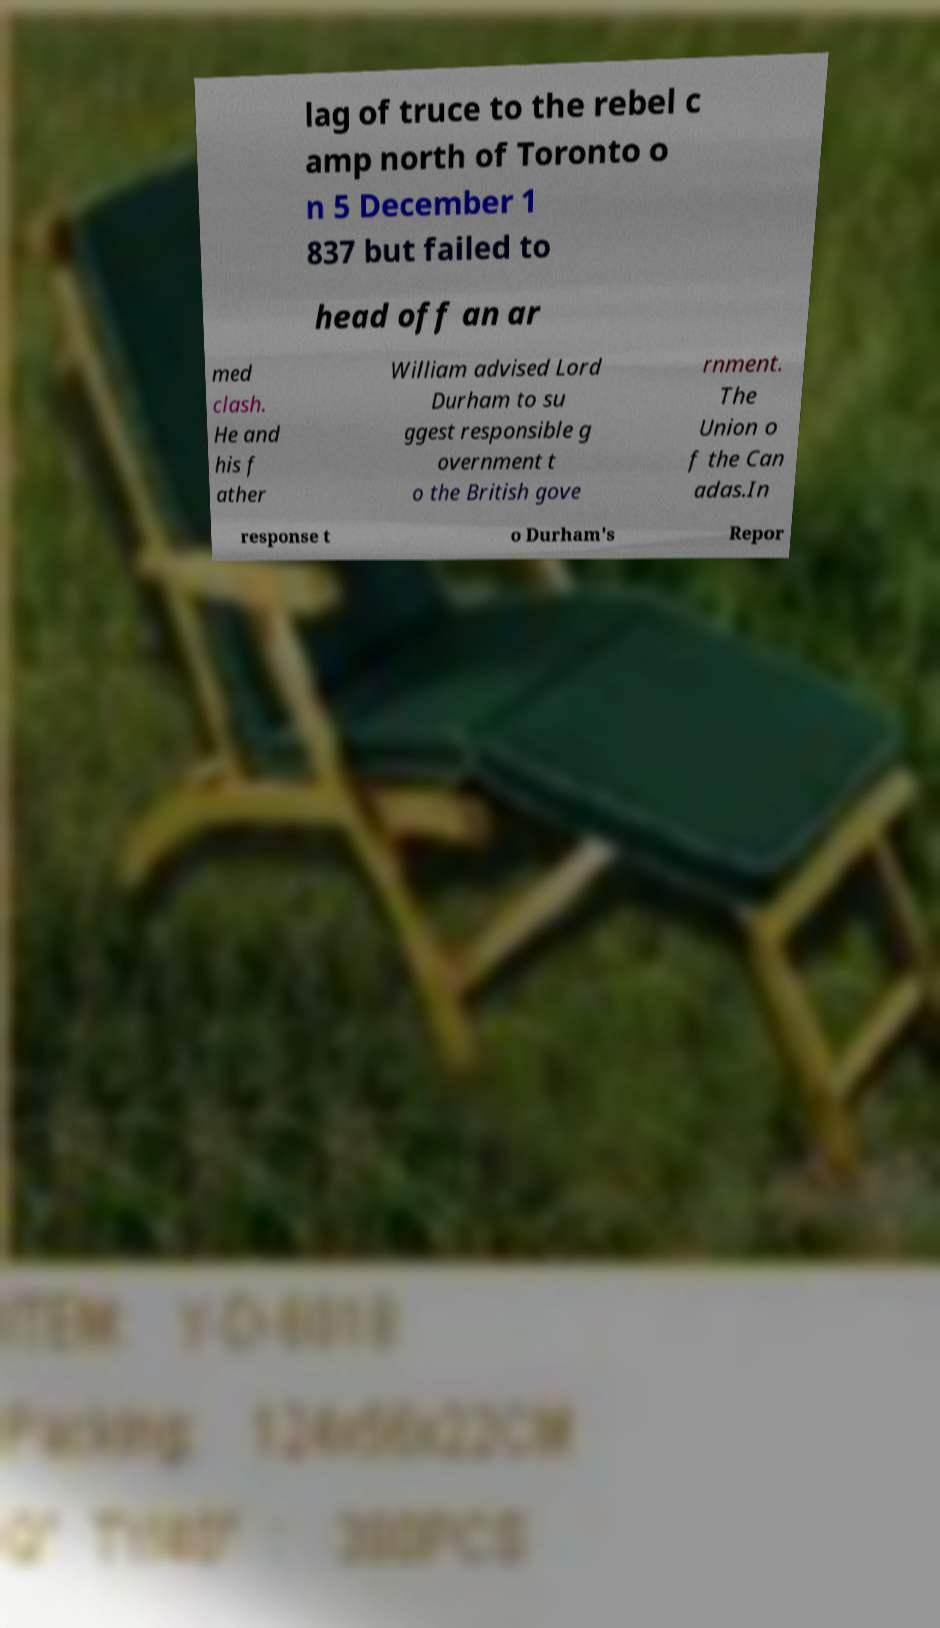There's text embedded in this image that I need extracted. Can you transcribe it verbatim? lag of truce to the rebel c amp north of Toronto o n 5 December 1 837 but failed to head off an ar med clash. He and his f ather William advised Lord Durham to su ggest responsible g overnment t o the British gove rnment. The Union o f the Can adas.In response t o Durham's Repor 